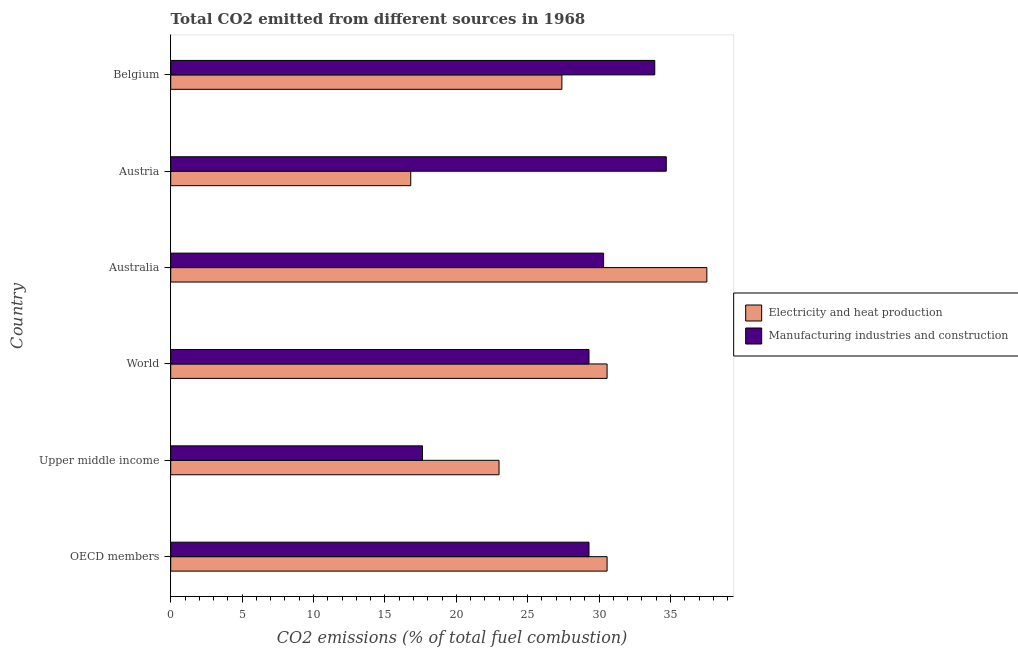How many different coloured bars are there?
Your answer should be compact. 2. How many groups of bars are there?
Keep it short and to the point. 6. How many bars are there on the 3rd tick from the top?
Your answer should be compact. 2. How many bars are there on the 3rd tick from the bottom?
Keep it short and to the point. 2. What is the label of the 5th group of bars from the top?
Your answer should be compact. Upper middle income. In how many cases, is the number of bars for a given country not equal to the number of legend labels?
Your answer should be compact. 0. What is the co2 emissions due to electricity and heat production in Belgium?
Your answer should be very brief. 27.4. Across all countries, what is the maximum co2 emissions due to manufacturing industries?
Offer a very short reply. 34.71. Across all countries, what is the minimum co2 emissions due to electricity and heat production?
Offer a very short reply. 16.81. In which country was the co2 emissions due to manufacturing industries maximum?
Provide a succinct answer. Austria. In which country was the co2 emissions due to manufacturing industries minimum?
Offer a very short reply. Upper middle income. What is the total co2 emissions due to electricity and heat production in the graph?
Keep it short and to the point. 165.87. What is the difference between the co2 emissions due to electricity and heat production in Austria and that in Belgium?
Your answer should be compact. -10.59. What is the difference between the co2 emissions due to electricity and heat production in Australia and the co2 emissions due to manufacturing industries in Upper middle income?
Keep it short and to the point. 19.92. What is the average co2 emissions due to electricity and heat production per country?
Your answer should be compact. 27.65. What is the difference between the co2 emissions due to manufacturing industries and co2 emissions due to electricity and heat production in OECD members?
Give a very brief answer. -1.27. What is the ratio of the co2 emissions due to electricity and heat production in Austria to that in Upper middle income?
Your answer should be very brief. 0.73. What is the difference between the highest and the second highest co2 emissions due to electricity and heat production?
Provide a succinct answer. 6.99. What is the difference between the highest and the lowest co2 emissions due to electricity and heat production?
Your response must be concise. 20.74. What does the 1st bar from the top in Austria represents?
Your answer should be compact. Manufacturing industries and construction. What does the 2nd bar from the bottom in World represents?
Ensure brevity in your answer.  Manufacturing industries and construction. Are all the bars in the graph horizontal?
Keep it short and to the point. Yes. How many countries are there in the graph?
Ensure brevity in your answer.  6. Does the graph contain grids?
Offer a very short reply. No. Where does the legend appear in the graph?
Your answer should be very brief. Center right. How many legend labels are there?
Make the answer very short. 2. What is the title of the graph?
Your answer should be compact. Total CO2 emitted from different sources in 1968. Does "Highest 10% of population" appear as one of the legend labels in the graph?
Provide a succinct answer. No. What is the label or title of the X-axis?
Your answer should be compact. CO2 emissions (% of total fuel combustion). What is the CO2 emissions (% of total fuel combustion) in Electricity and heat production in OECD members?
Ensure brevity in your answer.  30.56. What is the CO2 emissions (% of total fuel combustion) in Manufacturing industries and construction in OECD members?
Keep it short and to the point. 29.29. What is the CO2 emissions (% of total fuel combustion) of Electricity and heat production in Upper middle income?
Your response must be concise. 22.99. What is the CO2 emissions (% of total fuel combustion) in Manufacturing industries and construction in Upper middle income?
Offer a terse response. 17.63. What is the CO2 emissions (% of total fuel combustion) of Electricity and heat production in World?
Your answer should be very brief. 30.56. What is the CO2 emissions (% of total fuel combustion) of Manufacturing industries and construction in World?
Your answer should be very brief. 29.29. What is the CO2 emissions (% of total fuel combustion) of Electricity and heat production in Australia?
Keep it short and to the point. 37.55. What is the CO2 emissions (% of total fuel combustion) of Manufacturing industries and construction in Australia?
Keep it short and to the point. 30.32. What is the CO2 emissions (% of total fuel combustion) of Electricity and heat production in Austria?
Give a very brief answer. 16.81. What is the CO2 emissions (% of total fuel combustion) in Manufacturing industries and construction in Austria?
Your answer should be very brief. 34.71. What is the CO2 emissions (% of total fuel combustion) of Electricity and heat production in Belgium?
Offer a terse response. 27.4. What is the CO2 emissions (% of total fuel combustion) in Manufacturing industries and construction in Belgium?
Your answer should be compact. 33.9. Across all countries, what is the maximum CO2 emissions (% of total fuel combustion) in Electricity and heat production?
Provide a succinct answer. 37.55. Across all countries, what is the maximum CO2 emissions (% of total fuel combustion) in Manufacturing industries and construction?
Give a very brief answer. 34.71. Across all countries, what is the minimum CO2 emissions (% of total fuel combustion) in Electricity and heat production?
Keep it short and to the point. 16.81. Across all countries, what is the minimum CO2 emissions (% of total fuel combustion) in Manufacturing industries and construction?
Provide a short and direct response. 17.63. What is the total CO2 emissions (% of total fuel combustion) of Electricity and heat production in the graph?
Your answer should be compact. 165.87. What is the total CO2 emissions (% of total fuel combustion) in Manufacturing industries and construction in the graph?
Give a very brief answer. 175.15. What is the difference between the CO2 emissions (% of total fuel combustion) of Electricity and heat production in OECD members and that in Upper middle income?
Your answer should be compact. 7.57. What is the difference between the CO2 emissions (% of total fuel combustion) in Manufacturing industries and construction in OECD members and that in Upper middle income?
Offer a terse response. 11.66. What is the difference between the CO2 emissions (% of total fuel combustion) of Electricity and heat production in OECD members and that in World?
Ensure brevity in your answer.  0. What is the difference between the CO2 emissions (% of total fuel combustion) of Manufacturing industries and construction in OECD members and that in World?
Your response must be concise. 0. What is the difference between the CO2 emissions (% of total fuel combustion) in Electricity and heat production in OECD members and that in Australia?
Your response must be concise. -6.99. What is the difference between the CO2 emissions (% of total fuel combustion) in Manufacturing industries and construction in OECD members and that in Australia?
Your answer should be compact. -1.02. What is the difference between the CO2 emissions (% of total fuel combustion) in Electricity and heat production in OECD members and that in Austria?
Keep it short and to the point. 13.75. What is the difference between the CO2 emissions (% of total fuel combustion) of Manufacturing industries and construction in OECD members and that in Austria?
Provide a short and direct response. -5.41. What is the difference between the CO2 emissions (% of total fuel combustion) of Electricity and heat production in OECD members and that in Belgium?
Provide a succinct answer. 3.17. What is the difference between the CO2 emissions (% of total fuel combustion) of Manufacturing industries and construction in OECD members and that in Belgium?
Keep it short and to the point. -4.61. What is the difference between the CO2 emissions (% of total fuel combustion) of Electricity and heat production in Upper middle income and that in World?
Keep it short and to the point. -7.57. What is the difference between the CO2 emissions (% of total fuel combustion) in Manufacturing industries and construction in Upper middle income and that in World?
Ensure brevity in your answer.  -11.66. What is the difference between the CO2 emissions (% of total fuel combustion) in Electricity and heat production in Upper middle income and that in Australia?
Offer a terse response. -14.56. What is the difference between the CO2 emissions (% of total fuel combustion) in Manufacturing industries and construction in Upper middle income and that in Australia?
Keep it short and to the point. -12.68. What is the difference between the CO2 emissions (% of total fuel combustion) of Electricity and heat production in Upper middle income and that in Austria?
Make the answer very short. 6.18. What is the difference between the CO2 emissions (% of total fuel combustion) of Manufacturing industries and construction in Upper middle income and that in Austria?
Your response must be concise. -17.07. What is the difference between the CO2 emissions (% of total fuel combustion) in Electricity and heat production in Upper middle income and that in Belgium?
Your response must be concise. -4.4. What is the difference between the CO2 emissions (% of total fuel combustion) in Manufacturing industries and construction in Upper middle income and that in Belgium?
Your answer should be very brief. -16.27. What is the difference between the CO2 emissions (% of total fuel combustion) in Electricity and heat production in World and that in Australia?
Offer a very short reply. -6.99. What is the difference between the CO2 emissions (% of total fuel combustion) of Manufacturing industries and construction in World and that in Australia?
Make the answer very short. -1.02. What is the difference between the CO2 emissions (% of total fuel combustion) in Electricity and heat production in World and that in Austria?
Your response must be concise. 13.75. What is the difference between the CO2 emissions (% of total fuel combustion) in Manufacturing industries and construction in World and that in Austria?
Your answer should be very brief. -5.41. What is the difference between the CO2 emissions (% of total fuel combustion) of Electricity and heat production in World and that in Belgium?
Offer a terse response. 3.17. What is the difference between the CO2 emissions (% of total fuel combustion) in Manufacturing industries and construction in World and that in Belgium?
Your response must be concise. -4.61. What is the difference between the CO2 emissions (% of total fuel combustion) in Electricity and heat production in Australia and that in Austria?
Offer a very short reply. 20.74. What is the difference between the CO2 emissions (% of total fuel combustion) of Manufacturing industries and construction in Australia and that in Austria?
Keep it short and to the point. -4.39. What is the difference between the CO2 emissions (% of total fuel combustion) of Electricity and heat production in Australia and that in Belgium?
Give a very brief answer. 10.15. What is the difference between the CO2 emissions (% of total fuel combustion) of Manufacturing industries and construction in Australia and that in Belgium?
Provide a short and direct response. -3.58. What is the difference between the CO2 emissions (% of total fuel combustion) in Electricity and heat production in Austria and that in Belgium?
Provide a short and direct response. -10.59. What is the difference between the CO2 emissions (% of total fuel combustion) in Manufacturing industries and construction in Austria and that in Belgium?
Provide a short and direct response. 0.81. What is the difference between the CO2 emissions (% of total fuel combustion) of Electricity and heat production in OECD members and the CO2 emissions (% of total fuel combustion) of Manufacturing industries and construction in Upper middle income?
Provide a short and direct response. 12.93. What is the difference between the CO2 emissions (% of total fuel combustion) in Electricity and heat production in OECD members and the CO2 emissions (% of total fuel combustion) in Manufacturing industries and construction in World?
Offer a terse response. 1.27. What is the difference between the CO2 emissions (% of total fuel combustion) of Electricity and heat production in OECD members and the CO2 emissions (% of total fuel combustion) of Manufacturing industries and construction in Australia?
Offer a very short reply. 0.24. What is the difference between the CO2 emissions (% of total fuel combustion) in Electricity and heat production in OECD members and the CO2 emissions (% of total fuel combustion) in Manufacturing industries and construction in Austria?
Your response must be concise. -4.15. What is the difference between the CO2 emissions (% of total fuel combustion) of Electricity and heat production in OECD members and the CO2 emissions (% of total fuel combustion) of Manufacturing industries and construction in Belgium?
Offer a terse response. -3.34. What is the difference between the CO2 emissions (% of total fuel combustion) of Electricity and heat production in Upper middle income and the CO2 emissions (% of total fuel combustion) of Manufacturing industries and construction in World?
Give a very brief answer. -6.3. What is the difference between the CO2 emissions (% of total fuel combustion) in Electricity and heat production in Upper middle income and the CO2 emissions (% of total fuel combustion) in Manufacturing industries and construction in Australia?
Your answer should be compact. -7.32. What is the difference between the CO2 emissions (% of total fuel combustion) of Electricity and heat production in Upper middle income and the CO2 emissions (% of total fuel combustion) of Manufacturing industries and construction in Austria?
Give a very brief answer. -11.71. What is the difference between the CO2 emissions (% of total fuel combustion) of Electricity and heat production in Upper middle income and the CO2 emissions (% of total fuel combustion) of Manufacturing industries and construction in Belgium?
Ensure brevity in your answer.  -10.91. What is the difference between the CO2 emissions (% of total fuel combustion) in Electricity and heat production in World and the CO2 emissions (% of total fuel combustion) in Manufacturing industries and construction in Australia?
Your answer should be compact. 0.24. What is the difference between the CO2 emissions (% of total fuel combustion) of Electricity and heat production in World and the CO2 emissions (% of total fuel combustion) of Manufacturing industries and construction in Austria?
Offer a very short reply. -4.15. What is the difference between the CO2 emissions (% of total fuel combustion) in Electricity and heat production in World and the CO2 emissions (% of total fuel combustion) in Manufacturing industries and construction in Belgium?
Keep it short and to the point. -3.34. What is the difference between the CO2 emissions (% of total fuel combustion) in Electricity and heat production in Australia and the CO2 emissions (% of total fuel combustion) in Manufacturing industries and construction in Austria?
Ensure brevity in your answer.  2.84. What is the difference between the CO2 emissions (% of total fuel combustion) in Electricity and heat production in Australia and the CO2 emissions (% of total fuel combustion) in Manufacturing industries and construction in Belgium?
Give a very brief answer. 3.65. What is the difference between the CO2 emissions (% of total fuel combustion) in Electricity and heat production in Austria and the CO2 emissions (% of total fuel combustion) in Manufacturing industries and construction in Belgium?
Your answer should be compact. -17.09. What is the average CO2 emissions (% of total fuel combustion) of Electricity and heat production per country?
Provide a short and direct response. 27.65. What is the average CO2 emissions (% of total fuel combustion) of Manufacturing industries and construction per country?
Offer a very short reply. 29.19. What is the difference between the CO2 emissions (% of total fuel combustion) of Electricity and heat production and CO2 emissions (% of total fuel combustion) of Manufacturing industries and construction in OECD members?
Provide a short and direct response. 1.27. What is the difference between the CO2 emissions (% of total fuel combustion) of Electricity and heat production and CO2 emissions (% of total fuel combustion) of Manufacturing industries and construction in Upper middle income?
Offer a terse response. 5.36. What is the difference between the CO2 emissions (% of total fuel combustion) in Electricity and heat production and CO2 emissions (% of total fuel combustion) in Manufacturing industries and construction in World?
Offer a terse response. 1.27. What is the difference between the CO2 emissions (% of total fuel combustion) of Electricity and heat production and CO2 emissions (% of total fuel combustion) of Manufacturing industries and construction in Australia?
Offer a terse response. 7.23. What is the difference between the CO2 emissions (% of total fuel combustion) of Electricity and heat production and CO2 emissions (% of total fuel combustion) of Manufacturing industries and construction in Austria?
Your response must be concise. -17.9. What is the difference between the CO2 emissions (% of total fuel combustion) of Electricity and heat production and CO2 emissions (% of total fuel combustion) of Manufacturing industries and construction in Belgium?
Offer a terse response. -6.5. What is the ratio of the CO2 emissions (% of total fuel combustion) of Electricity and heat production in OECD members to that in Upper middle income?
Give a very brief answer. 1.33. What is the ratio of the CO2 emissions (% of total fuel combustion) of Manufacturing industries and construction in OECD members to that in Upper middle income?
Offer a terse response. 1.66. What is the ratio of the CO2 emissions (% of total fuel combustion) of Electricity and heat production in OECD members to that in Australia?
Give a very brief answer. 0.81. What is the ratio of the CO2 emissions (% of total fuel combustion) of Manufacturing industries and construction in OECD members to that in Australia?
Make the answer very short. 0.97. What is the ratio of the CO2 emissions (% of total fuel combustion) in Electricity and heat production in OECD members to that in Austria?
Make the answer very short. 1.82. What is the ratio of the CO2 emissions (% of total fuel combustion) of Manufacturing industries and construction in OECD members to that in Austria?
Offer a very short reply. 0.84. What is the ratio of the CO2 emissions (% of total fuel combustion) of Electricity and heat production in OECD members to that in Belgium?
Provide a succinct answer. 1.12. What is the ratio of the CO2 emissions (% of total fuel combustion) of Manufacturing industries and construction in OECD members to that in Belgium?
Keep it short and to the point. 0.86. What is the ratio of the CO2 emissions (% of total fuel combustion) in Electricity and heat production in Upper middle income to that in World?
Provide a short and direct response. 0.75. What is the ratio of the CO2 emissions (% of total fuel combustion) in Manufacturing industries and construction in Upper middle income to that in World?
Ensure brevity in your answer.  0.6. What is the ratio of the CO2 emissions (% of total fuel combustion) in Electricity and heat production in Upper middle income to that in Australia?
Your answer should be very brief. 0.61. What is the ratio of the CO2 emissions (% of total fuel combustion) in Manufacturing industries and construction in Upper middle income to that in Australia?
Provide a succinct answer. 0.58. What is the ratio of the CO2 emissions (% of total fuel combustion) in Electricity and heat production in Upper middle income to that in Austria?
Make the answer very short. 1.37. What is the ratio of the CO2 emissions (% of total fuel combustion) in Manufacturing industries and construction in Upper middle income to that in Austria?
Ensure brevity in your answer.  0.51. What is the ratio of the CO2 emissions (% of total fuel combustion) in Electricity and heat production in Upper middle income to that in Belgium?
Offer a very short reply. 0.84. What is the ratio of the CO2 emissions (% of total fuel combustion) of Manufacturing industries and construction in Upper middle income to that in Belgium?
Your answer should be very brief. 0.52. What is the ratio of the CO2 emissions (% of total fuel combustion) in Electricity and heat production in World to that in Australia?
Your answer should be very brief. 0.81. What is the ratio of the CO2 emissions (% of total fuel combustion) of Manufacturing industries and construction in World to that in Australia?
Offer a terse response. 0.97. What is the ratio of the CO2 emissions (% of total fuel combustion) of Electricity and heat production in World to that in Austria?
Your response must be concise. 1.82. What is the ratio of the CO2 emissions (% of total fuel combustion) in Manufacturing industries and construction in World to that in Austria?
Ensure brevity in your answer.  0.84. What is the ratio of the CO2 emissions (% of total fuel combustion) of Electricity and heat production in World to that in Belgium?
Provide a succinct answer. 1.12. What is the ratio of the CO2 emissions (% of total fuel combustion) of Manufacturing industries and construction in World to that in Belgium?
Make the answer very short. 0.86. What is the ratio of the CO2 emissions (% of total fuel combustion) in Electricity and heat production in Australia to that in Austria?
Provide a short and direct response. 2.23. What is the ratio of the CO2 emissions (% of total fuel combustion) in Manufacturing industries and construction in Australia to that in Austria?
Offer a terse response. 0.87. What is the ratio of the CO2 emissions (% of total fuel combustion) of Electricity and heat production in Australia to that in Belgium?
Ensure brevity in your answer.  1.37. What is the ratio of the CO2 emissions (% of total fuel combustion) of Manufacturing industries and construction in Australia to that in Belgium?
Your answer should be very brief. 0.89. What is the ratio of the CO2 emissions (% of total fuel combustion) in Electricity and heat production in Austria to that in Belgium?
Make the answer very short. 0.61. What is the ratio of the CO2 emissions (% of total fuel combustion) in Manufacturing industries and construction in Austria to that in Belgium?
Your response must be concise. 1.02. What is the difference between the highest and the second highest CO2 emissions (% of total fuel combustion) of Electricity and heat production?
Your response must be concise. 6.99. What is the difference between the highest and the second highest CO2 emissions (% of total fuel combustion) in Manufacturing industries and construction?
Offer a very short reply. 0.81. What is the difference between the highest and the lowest CO2 emissions (% of total fuel combustion) of Electricity and heat production?
Offer a terse response. 20.74. What is the difference between the highest and the lowest CO2 emissions (% of total fuel combustion) in Manufacturing industries and construction?
Ensure brevity in your answer.  17.07. 